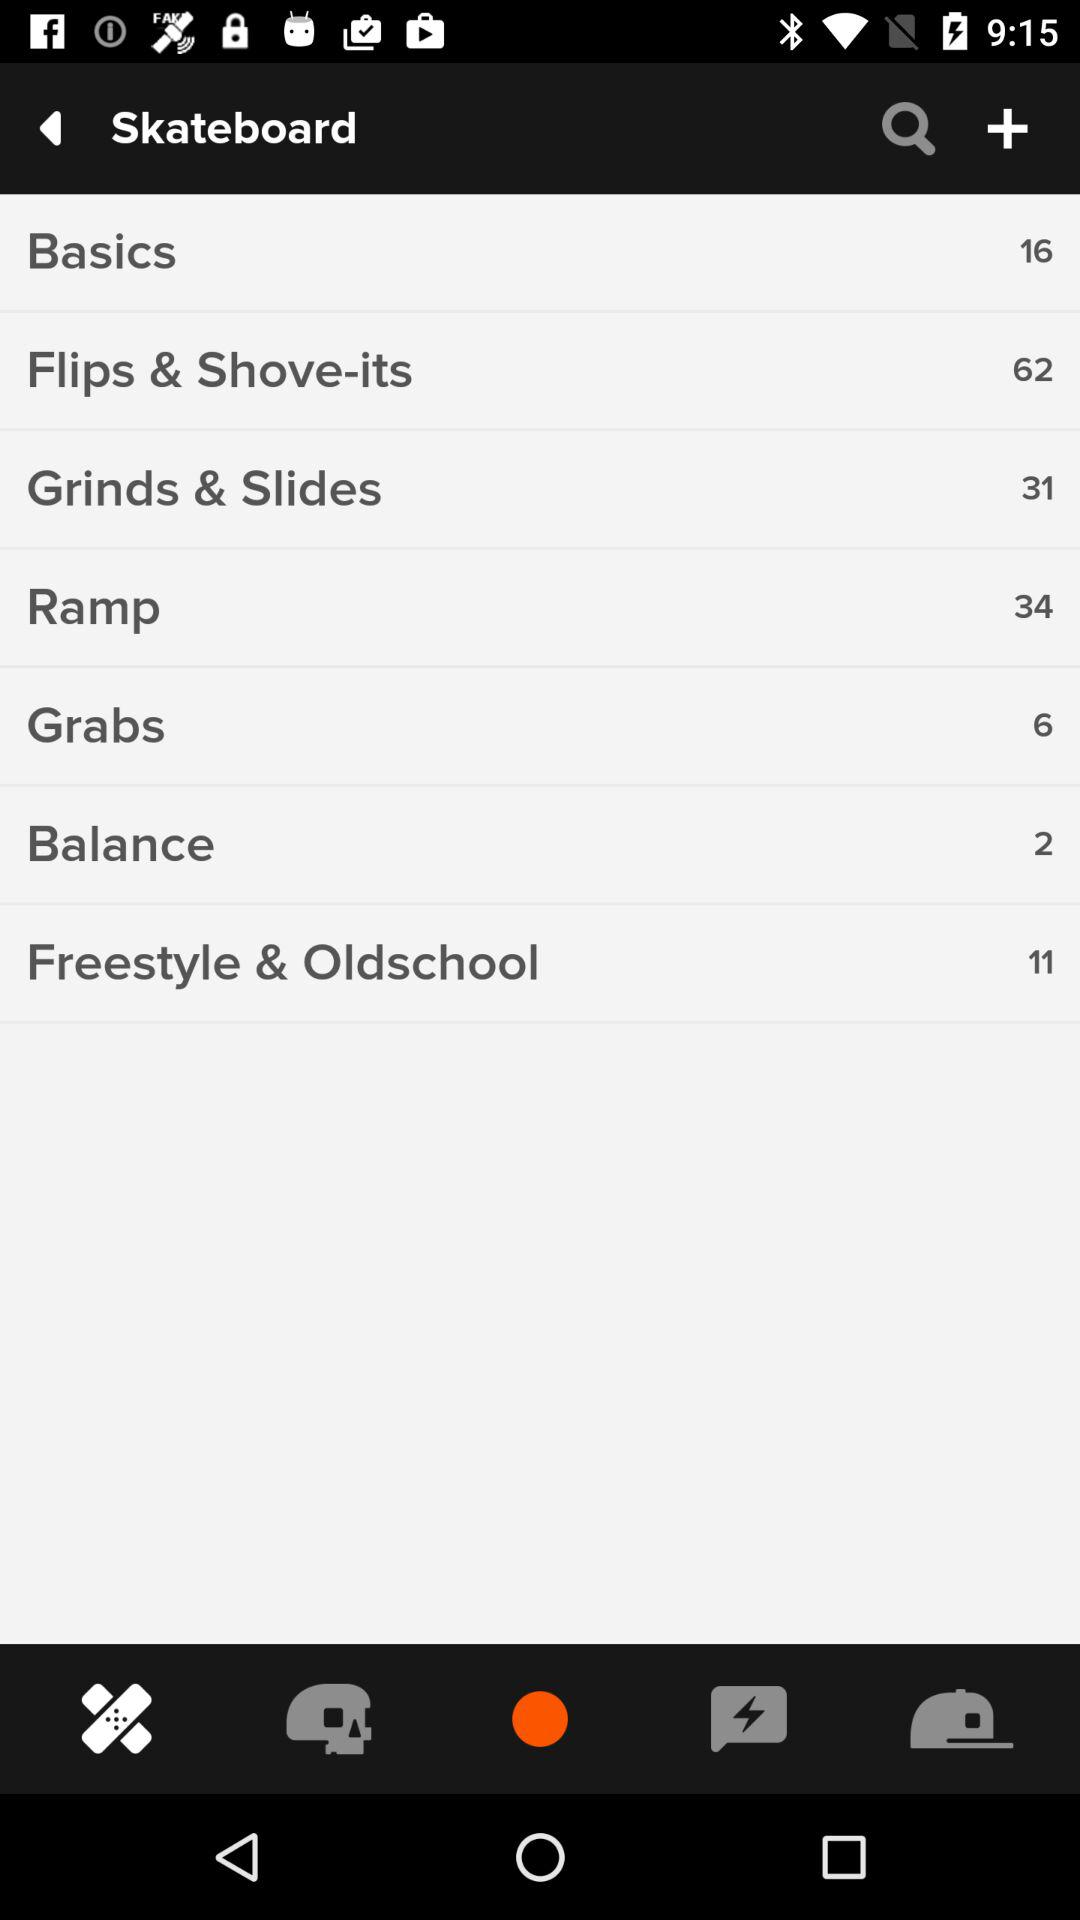How many "Basics" tricks are there on a skateboard? There are 16 "Basics" tricks. 